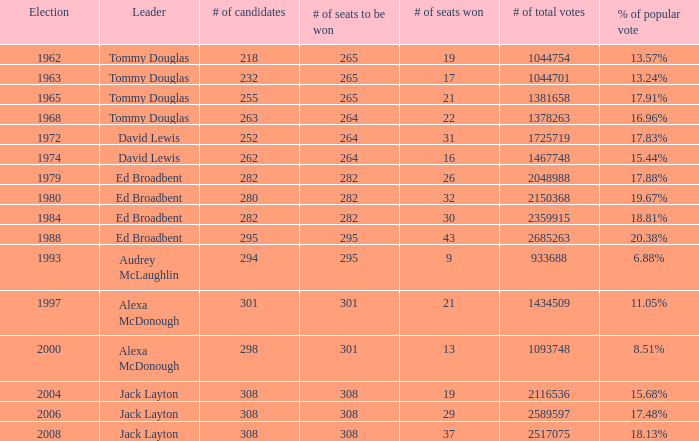Name the number of seats to be won being % of popular vote at 6.88% 295.0. 